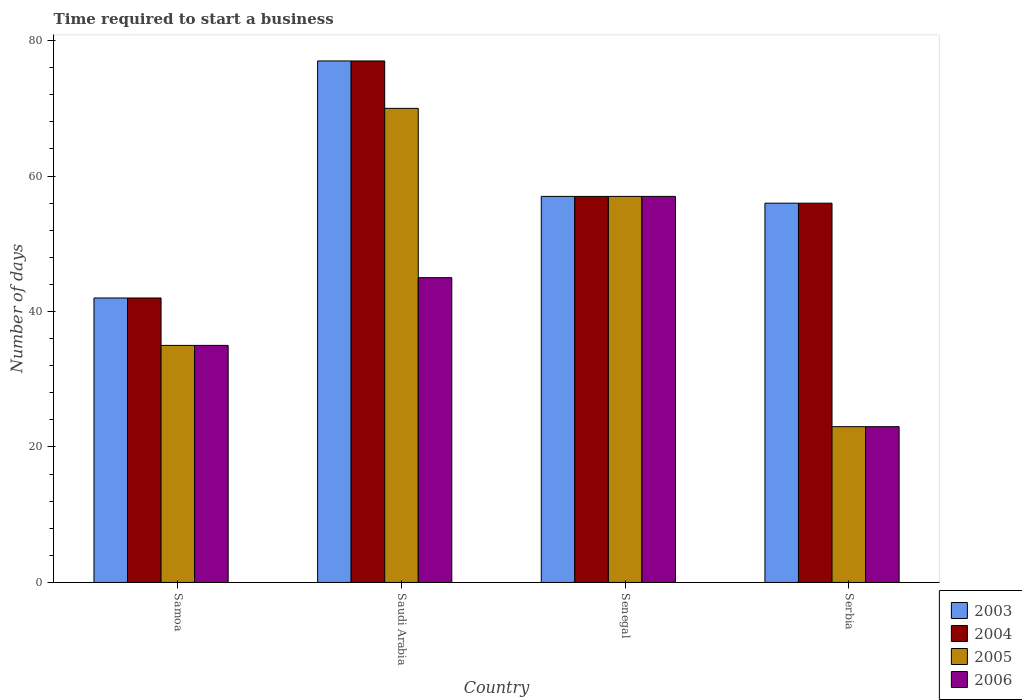How many different coloured bars are there?
Provide a short and direct response. 4. How many groups of bars are there?
Offer a terse response. 4. Are the number of bars per tick equal to the number of legend labels?
Give a very brief answer. Yes. Are the number of bars on each tick of the X-axis equal?
Ensure brevity in your answer.  Yes. How many bars are there on the 1st tick from the right?
Provide a short and direct response. 4. What is the label of the 4th group of bars from the left?
Offer a terse response. Serbia. Across all countries, what is the maximum number of days required to start a business in 2004?
Your answer should be very brief. 77. In which country was the number of days required to start a business in 2006 maximum?
Offer a terse response. Senegal. In which country was the number of days required to start a business in 2003 minimum?
Your answer should be compact. Samoa. What is the total number of days required to start a business in 2006 in the graph?
Your response must be concise. 160. What is the difference between the number of days required to start a business in 2004 in Samoa and that in Saudi Arabia?
Your answer should be very brief. -35. What is the average number of days required to start a business in 2006 per country?
Give a very brief answer. 40. What is the ratio of the number of days required to start a business in 2004 in Saudi Arabia to that in Senegal?
Your answer should be very brief. 1.35. Is the number of days required to start a business in 2003 in Samoa less than that in Serbia?
Offer a terse response. Yes. What is the difference between the highest and the second highest number of days required to start a business in 2004?
Your answer should be compact. -1. Is the sum of the number of days required to start a business in 2005 in Senegal and Serbia greater than the maximum number of days required to start a business in 2003 across all countries?
Keep it short and to the point. Yes. Is it the case that in every country, the sum of the number of days required to start a business in 2003 and number of days required to start a business in 2006 is greater than the sum of number of days required to start a business in 2004 and number of days required to start a business in 2005?
Ensure brevity in your answer.  No. What does the 4th bar from the left in Samoa represents?
Keep it short and to the point. 2006. How many bars are there?
Give a very brief answer. 16. What is the difference between two consecutive major ticks on the Y-axis?
Provide a short and direct response. 20. Does the graph contain any zero values?
Ensure brevity in your answer.  No. Where does the legend appear in the graph?
Make the answer very short. Bottom right. How many legend labels are there?
Ensure brevity in your answer.  4. How are the legend labels stacked?
Ensure brevity in your answer.  Vertical. What is the title of the graph?
Your response must be concise. Time required to start a business. Does "1964" appear as one of the legend labels in the graph?
Your response must be concise. No. What is the label or title of the X-axis?
Provide a succinct answer. Country. What is the label or title of the Y-axis?
Offer a very short reply. Number of days. What is the Number of days of 2003 in Samoa?
Your response must be concise. 42. What is the Number of days of 2004 in Samoa?
Your answer should be compact. 42. What is the Number of days in 2005 in Samoa?
Give a very brief answer. 35. What is the Number of days in 2006 in Samoa?
Provide a succinct answer. 35. What is the Number of days of 2003 in Saudi Arabia?
Offer a very short reply. 77. What is the Number of days in 2004 in Saudi Arabia?
Provide a short and direct response. 77. What is the Number of days of 2005 in Saudi Arabia?
Your answer should be compact. 70. What is the Number of days in 2003 in Senegal?
Give a very brief answer. 57. What is the Number of days in 2004 in Senegal?
Provide a succinct answer. 57. What is the Number of days in 2006 in Senegal?
Give a very brief answer. 57. What is the Number of days in 2003 in Serbia?
Offer a very short reply. 56. What is the Number of days of 2006 in Serbia?
Ensure brevity in your answer.  23. Across all countries, what is the maximum Number of days of 2003?
Keep it short and to the point. 77. Across all countries, what is the minimum Number of days in 2003?
Your answer should be very brief. 42. Across all countries, what is the minimum Number of days in 2004?
Your answer should be very brief. 42. Across all countries, what is the minimum Number of days in 2005?
Keep it short and to the point. 23. Across all countries, what is the minimum Number of days of 2006?
Your response must be concise. 23. What is the total Number of days of 2003 in the graph?
Your response must be concise. 232. What is the total Number of days of 2004 in the graph?
Your answer should be very brief. 232. What is the total Number of days in 2005 in the graph?
Keep it short and to the point. 185. What is the total Number of days of 2006 in the graph?
Your answer should be compact. 160. What is the difference between the Number of days in 2003 in Samoa and that in Saudi Arabia?
Your response must be concise. -35. What is the difference between the Number of days of 2004 in Samoa and that in Saudi Arabia?
Give a very brief answer. -35. What is the difference between the Number of days of 2005 in Samoa and that in Saudi Arabia?
Provide a succinct answer. -35. What is the difference between the Number of days of 2003 in Samoa and that in Senegal?
Ensure brevity in your answer.  -15. What is the difference between the Number of days in 2003 in Samoa and that in Serbia?
Your answer should be compact. -14. What is the difference between the Number of days in 2005 in Samoa and that in Serbia?
Ensure brevity in your answer.  12. What is the difference between the Number of days of 2006 in Samoa and that in Serbia?
Offer a terse response. 12. What is the difference between the Number of days in 2003 in Saudi Arabia and that in Senegal?
Provide a succinct answer. 20. What is the difference between the Number of days in 2005 in Saudi Arabia and that in Senegal?
Ensure brevity in your answer.  13. What is the difference between the Number of days of 2004 in Saudi Arabia and that in Serbia?
Ensure brevity in your answer.  21. What is the difference between the Number of days in 2005 in Saudi Arabia and that in Serbia?
Provide a short and direct response. 47. What is the difference between the Number of days of 2006 in Saudi Arabia and that in Serbia?
Ensure brevity in your answer.  22. What is the difference between the Number of days in 2003 in Senegal and that in Serbia?
Your answer should be very brief. 1. What is the difference between the Number of days in 2004 in Senegal and that in Serbia?
Ensure brevity in your answer.  1. What is the difference between the Number of days of 2006 in Senegal and that in Serbia?
Make the answer very short. 34. What is the difference between the Number of days of 2003 in Samoa and the Number of days of 2004 in Saudi Arabia?
Your response must be concise. -35. What is the difference between the Number of days of 2003 in Samoa and the Number of days of 2006 in Saudi Arabia?
Your answer should be very brief. -3. What is the difference between the Number of days of 2003 in Samoa and the Number of days of 2005 in Senegal?
Offer a terse response. -15. What is the difference between the Number of days in 2003 in Samoa and the Number of days in 2006 in Senegal?
Your answer should be very brief. -15. What is the difference between the Number of days of 2004 in Samoa and the Number of days of 2005 in Senegal?
Keep it short and to the point. -15. What is the difference between the Number of days in 2004 in Samoa and the Number of days in 2006 in Senegal?
Offer a very short reply. -15. What is the difference between the Number of days in 2005 in Samoa and the Number of days in 2006 in Senegal?
Your answer should be very brief. -22. What is the difference between the Number of days in 2003 in Samoa and the Number of days in 2005 in Serbia?
Offer a terse response. 19. What is the difference between the Number of days in 2004 in Samoa and the Number of days in 2006 in Serbia?
Offer a terse response. 19. What is the difference between the Number of days of 2003 in Saudi Arabia and the Number of days of 2004 in Senegal?
Keep it short and to the point. 20. What is the difference between the Number of days of 2003 in Saudi Arabia and the Number of days of 2005 in Senegal?
Offer a very short reply. 20. What is the difference between the Number of days of 2003 in Saudi Arabia and the Number of days of 2005 in Serbia?
Your response must be concise. 54. What is the difference between the Number of days in 2003 in Saudi Arabia and the Number of days in 2006 in Serbia?
Provide a short and direct response. 54. What is the difference between the Number of days in 2004 in Saudi Arabia and the Number of days in 2005 in Serbia?
Your answer should be compact. 54. What is the difference between the Number of days in 2005 in Saudi Arabia and the Number of days in 2006 in Serbia?
Provide a short and direct response. 47. What is the difference between the Number of days of 2003 in Senegal and the Number of days of 2004 in Serbia?
Provide a succinct answer. 1. What is the difference between the Number of days in 2003 in Senegal and the Number of days in 2006 in Serbia?
Make the answer very short. 34. What is the difference between the Number of days of 2004 in Senegal and the Number of days of 2005 in Serbia?
Ensure brevity in your answer.  34. What is the difference between the Number of days of 2004 in Senegal and the Number of days of 2006 in Serbia?
Make the answer very short. 34. What is the difference between the Number of days of 2005 in Senegal and the Number of days of 2006 in Serbia?
Provide a succinct answer. 34. What is the average Number of days of 2003 per country?
Give a very brief answer. 58. What is the average Number of days of 2005 per country?
Give a very brief answer. 46.25. What is the average Number of days of 2006 per country?
Give a very brief answer. 40. What is the difference between the Number of days of 2003 and Number of days of 2004 in Samoa?
Your response must be concise. 0. What is the difference between the Number of days of 2004 and Number of days of 2006 in Samoa?
Keep it short and to the point. 7. What is the difference between the Number of days of 2003 and Number of days of 2004 in Saudi Arabia?
Provide a short and direct response. 0. What is the difference between the Number of days in 2003 and Number of days in 2005 in Saudi Arabia?
Your answer should be compact. 7. What is the difference between the Number of days in 2003 and Number of days in 2006 in Saudi Arabia?
Keep it short and to the point. 32. What is the difference between the Number of days in 2003 and Number of days in 2006 in Senegal?
Your answer should be very brief. 0. What is the difference between the Number of days in 2004 and Number of days in 2005 in Senegal?
Your response must be concise. 0. What is the difference between the Number of days in 2004 and Number of days in 2006 in Senegal?
Offer a terse response. 0. What is the difference between the Number of days of 2003 and Number of days of 2005 in Serbia?
Your answer should be very brief. 33. What is the difference between the Number of days in 2004 and Number of days in 2005 in Serbia?
Your answer should be compact. 33. What is the ratio of the Number of days in 2003 in Samoa to that in Saudi Arabia?
Your answer should be very brief. 0.55. What is the ratio of the Number of days in 2004 in Samoa to that in Saudi Arabia?
Offer a terse response. 0.55. What is the ratio of the Number of days of 2005 in Samoa to that in Saudi Arabia?
Ensure brevity in your answer.  0.5. What is the ratio of the Number of days of 2006 in Samoa to that in Saudi Arabia?
Keep it short and to the point. 0.78. What is the ratio of the Number of days in 2003 in Samoa to that in Senegal?
Make the answer very short. 0.74. What is the ratio of the Number of days in 2004 in Samoa to that in Senegal?
Give a very brief answer. 0.74. What is the ratio of the Number of days in 2005 in Samoa to that in Senegal?
Your response must be concise. 0.61. What is the ratio of the Number of days in 2006 in Samoa to that in Senegal?
Your response must be concise. 0.61. What is the ratio of the Number of days in 2004 in Samoa to that in Serbia?
Ensure brevity in your answer.  0.75. What is the ratio of the Number of days of 2005 in Samoa to that in Serbia?
Your answer should be compact. 1.52. What is the ratio of the Number of days in 2006 in Samoa to that in Serbia?
Provide a short and direct response. 1.52. What is the ratio of the Number of days in 2003 in Saudi Arabia to that in Senegal?
Your answer should be very brief. 1.35. What is the ratio of the Number of days of 2004 in Saudi Arabia to that in Senegal?
Offer a terse response. 1.35. What is the ratio of the Number of days of 2005 in Saudi Arabia to that in Senegal?
Provide a short and direct response. 1.23. What is the ratio of the Number of days in 2006 in Saudi Arabia to that in Senegal?
Ensure brevity in your answer.  0.79. What is the ratio of the Number of days in 2003 in Saudi Arabia to that in Serbia?
Ensure brevity in your answer.  1.38. What is the ratio of the Number of days in 2004 in Saudi Arabia to that in Serbia?
Your response must be concise. 1.38. What is the ratio of the Number of days in 2005 in Saudi Arabia to that in Serbia?
Your answer should be compact. 3.04. What is the ratio of the Number of days of 2006 in Saudi Arabia to that in Serbia?
Your response must be concise. 1.96. What is the ratio of the Number of days in 2003 in Senegal to that in Serbia?
Give a very brief answer. 1.02. What is the ratio of the Number of days in 2004 in Senegal to that in Serbia?
Keep it short and to the point. 1.02. What is the ratio of the Number of days in 2005 in Senegal to that in Serbia?
Make the answer very short. 2.48. What is the ratio of the Number of days in 2006 in Senegal to that in Serbia?
Make the answer very short. 2.48. What is the difference between the highest and the second highest Number of days in 2003?
Make the answer very short. 20. What is the difference between the highest and the second highest Number of days of 2006?
Your answer should be very brief. 12. What is the difference between the highest and the lowest Number of days in 2004?
Give a very brief answer. 35. What is the difference between the highest and the lowest Number of days of 2005?
Offer a terse response. 47. 